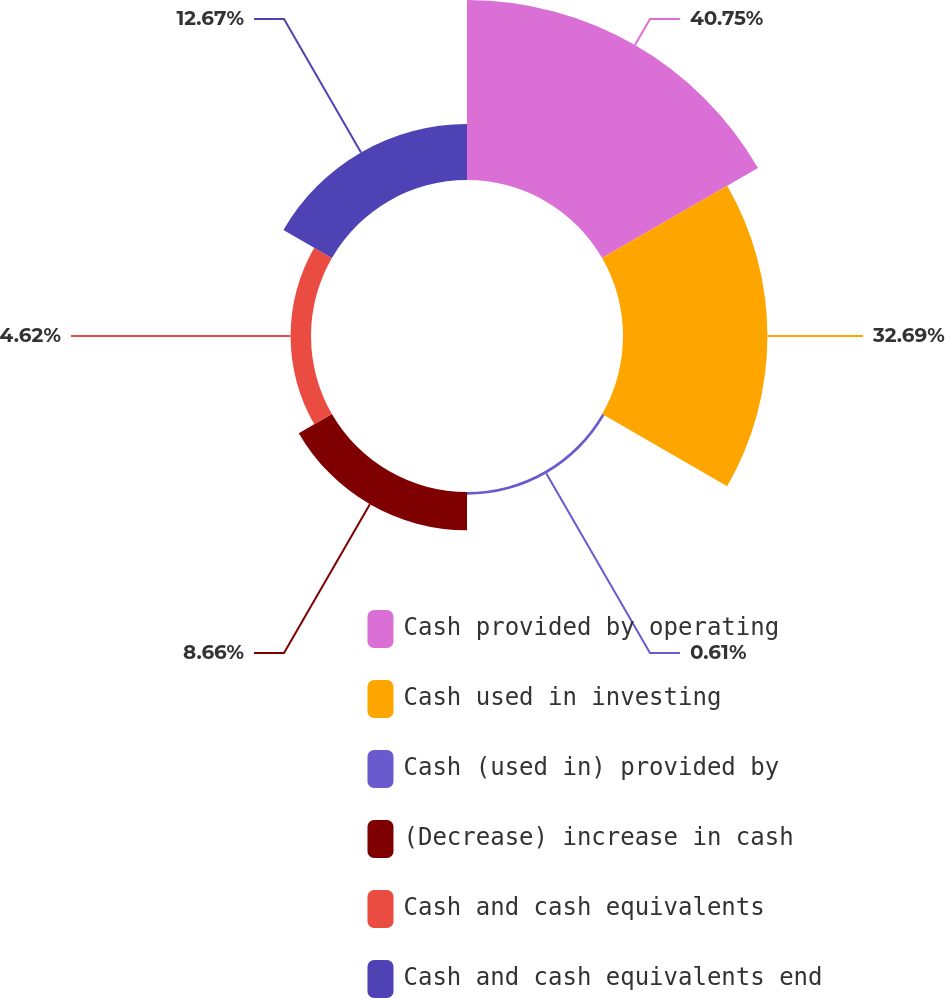Convert chart. <chart><loc_0><loc_0><loc_500><loc_500><pie_chart><fcel>Cash provided by operating<fcel>Cash used in investing<fcel>Cash (used in) provided by<fcel>(Decrease) increase in cash<fcel>Cash and cash equivalents<fcel>Cash and cash equivalents end<nl><fcel>40.74%<fcel>32.69%<fcel>0.61%<fcel>8.66%<fcel>4.62%<fcel>12.67%<nl></chart> 